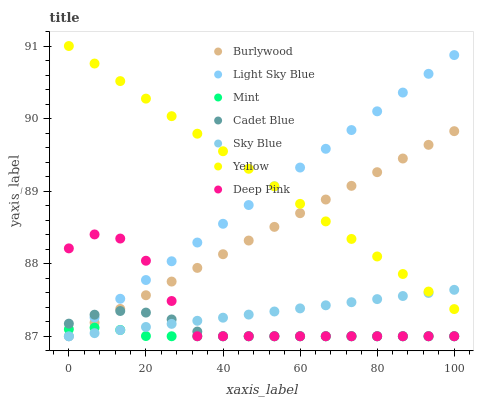Does Mint have the minimum area under the curve?
Answer yes or no. Yes. Does Yellow have the maximum area under the curve?
Answer yes or no. Yes. Does Deep Pink have the minimum area under the curve?
Answer yes or no. No. Does Deep Pink have the maximum area under the curve?
Answer yes or no. No. Is Sky Blue the smoothest?
Answer yes or no. Yes. Is Deep Pink the roughest?
Answer yes or no. Yes. Is Burlywood the smoothest?
Answer yes or no. No. Is Burlywood the roughest?
Answer yes or no. No. Does Cadet Blue have the lowest value?
Answer yes or no. Yes. Does Yellow have the lowest value?
Answer yes or no. No. Does Yellow have the highest value?
Answer yes or no. Yes. Does Deep Pink have the highest value?
Answer yes or no. No. Is Mint less than Yellow?
Answer yes or no. Yes. Is Yellow greater than Deep Pink?
Answer yes or no. Yes. Does Sky Blue intersect Light Sky Blue?
Answer yes or no. Yes. Is Sky Blue less than Light Sky Blue?
Answer yes or no. No. Is Sky Blue greater than Light Sky Blue?
Answer yes or no. No. Does Mint intersect Yellow?
Answer yes or no. No. 